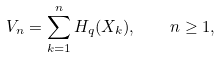<formula> <loc_0><loc_0><loc_500><loc_500>V _ { n } = \sum _ { k = 1 } ^ { n } H _ { q } ( X _ { k } ) , \quad n \geq 1 ,</formula> 